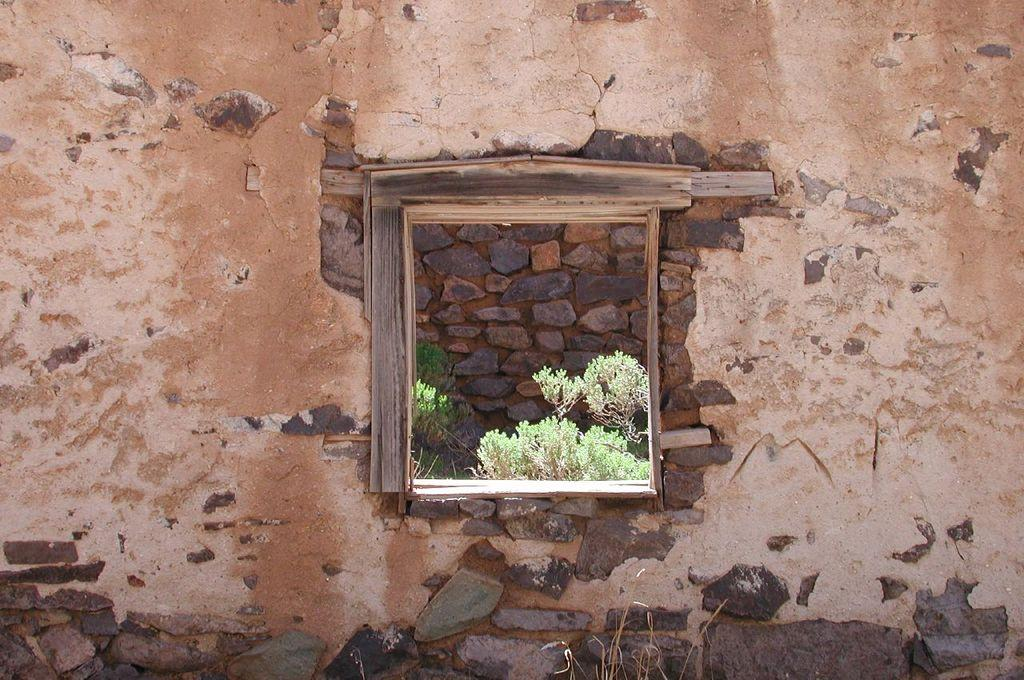What type of structure is present in the image? There is an old wall in the image. What feature can be seen on the old wall? The old wall has a window. What is around the window on the old wall? There is a wooden frame around the window. What else can be seen in the image besides the old wall? There is another wall visible in the image. What can be observed through the window in the image? Plants are visible through the window. What type of advertisement can be seen on the hands in the image? There are no hands or advertisements present in the image. What type of berry can be seen growing on the old wall in the image? There are no berries visible on the old wall in the image. 